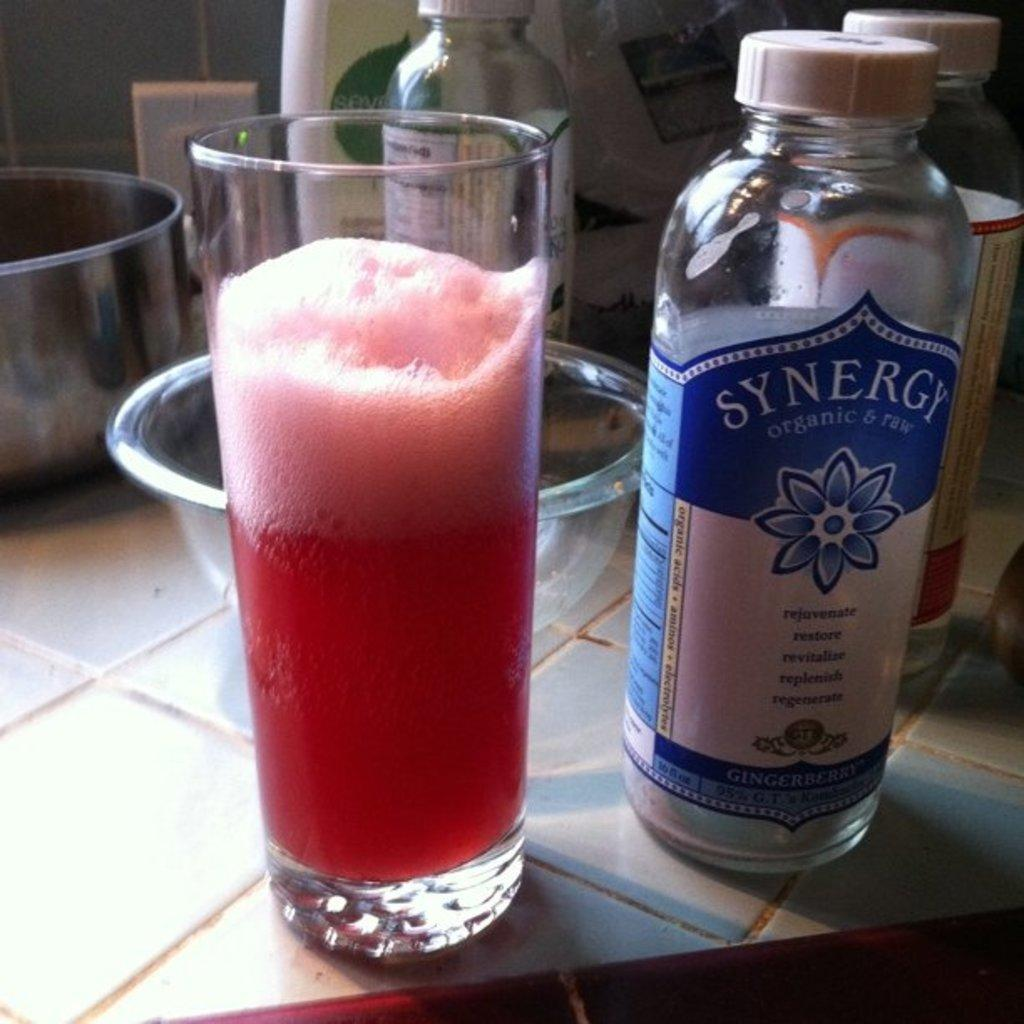<image>
Describe the image concisely. A bottle of Synergy sits on counter next to glass with a pink beverage. 